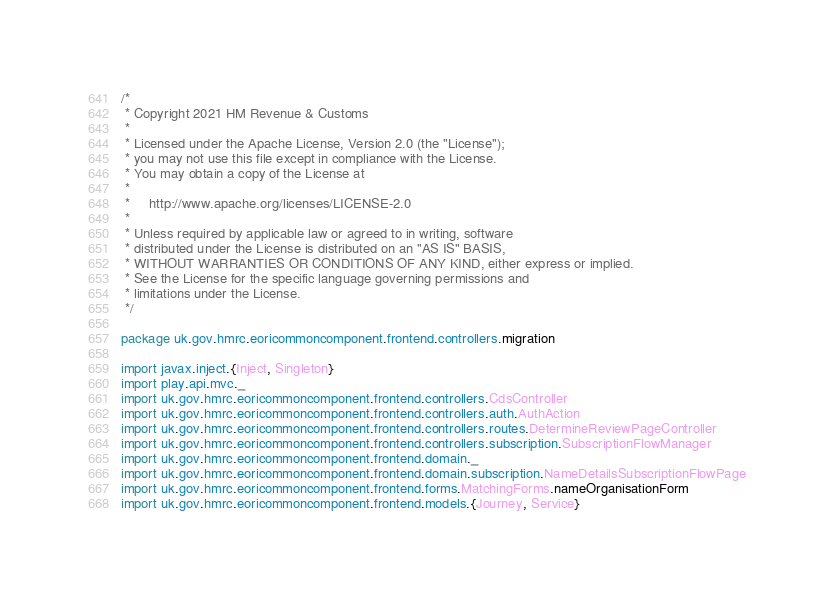Convert code to text. <code><loc_0><loc_0><loc_500><loc_500><_Scala_>/*
 * Copyright 2021 HM Revenue & Customs
 *
 * Licensed under the Apache License, Version 2.0 (the "License");
 * you may not use this file except in compliance with the License.
 * You may obtain a copy of the License at
 *
 *     http://www.apache.org/licenses/LICENSE-2.0
 *
 * Unless required by applicable law or agreed to in writing, software
 * distributed under the License is distributed on an "AS IS" BASIS,
 * WITHOUT WARRANTIES OR CONDITIONS OF ANY KIND, either express or implied.
 * See the License for the specific language governing permissions and
 * limitations under the License.
 */

package uk.gov.hmrc.eoricommoncomponent.frontend.controllers.migration

import javax.inject.{Inject, Singleton}
import play.api.mvc._
import uk.gov.hmrc.eoricommoncomponent.frontend.controllers.CdsController
import uk.gov.hmrc.eoricommoncomponent.frontend.controllers.auth.AuthAction
import uk.gov.hmrc.eoricommoncomponent.frontend.controllers.routes.DetermineReviewPageController
import uk.gov.hmrc.eoricommoncomponent.frontend.controllers.subscription.SubscriptionFlowManager
import uk.gov.hmrc.eoricommoncomponent.frontend.domain._
import uk.gov.hmrc.eoricommoncomponent.frontend.domain.subscription.NameDetailsSubscriptionFlowPage
import uk.gov.hmrc.eoricommoncomponent.frontend.forms.MatchingForms.nameOrganisationForm
import uk.gov.hmrc.eoricommoncomponent.frontend.models.{Journey, Service}</code> 